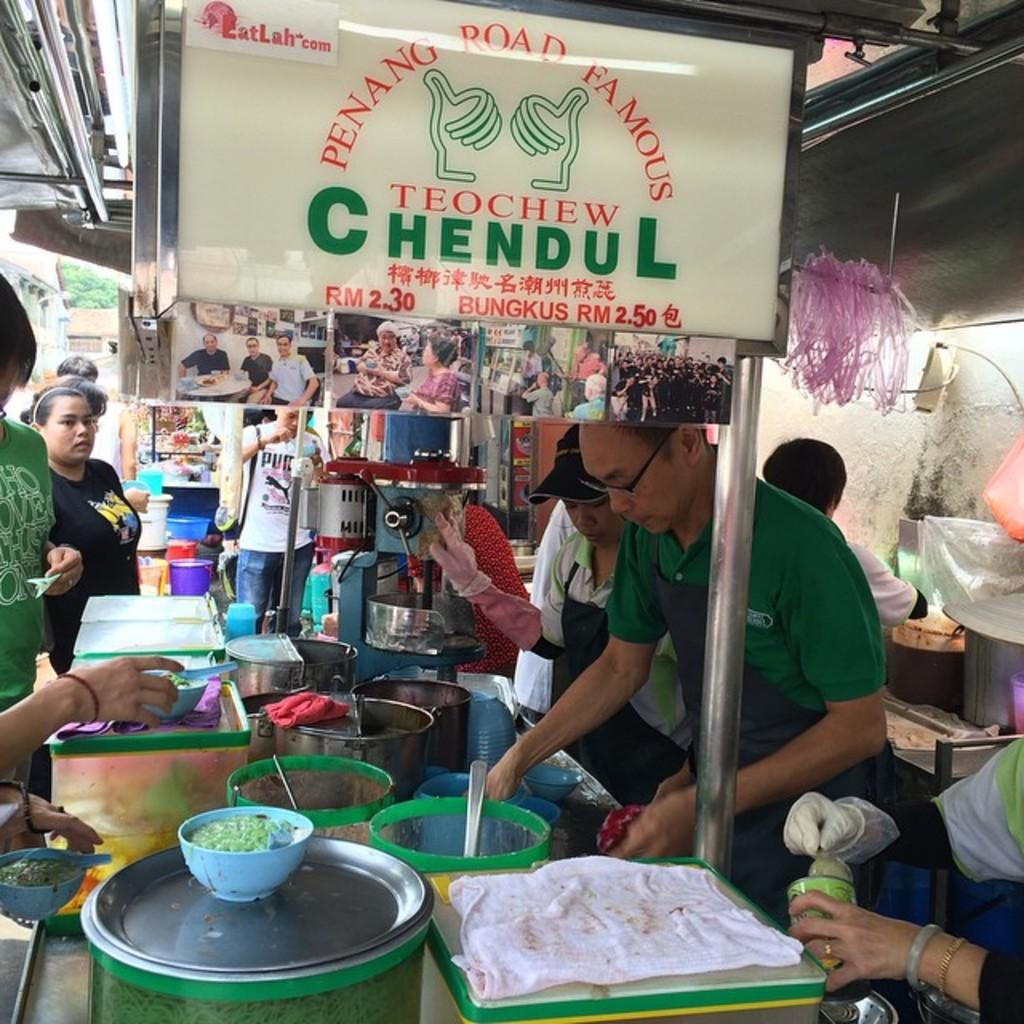What type of establishment can be seen in the image? There are food stalls in the image. Can you describe the people in the image? There is one person and other persons visible in the image. What is hanging on the wall or displayed in the image? There is a poster and an advertisement in the image. What items might be used for eating or serving food in the image? Utensils are present in the image. What type of structure is visible in the background of the image? There is a building in the image. What type of plant is visible in the image? There is a tree in the image. What type of sleet can be seen falling from the tree in the image? There is no sleet present in the image; it is a tree without any precipitation. How is the person's uncle related to the food stalls in the image? There is no mention of an uncle in the image or the provided facts, so it is not possible to determine any relationship. 